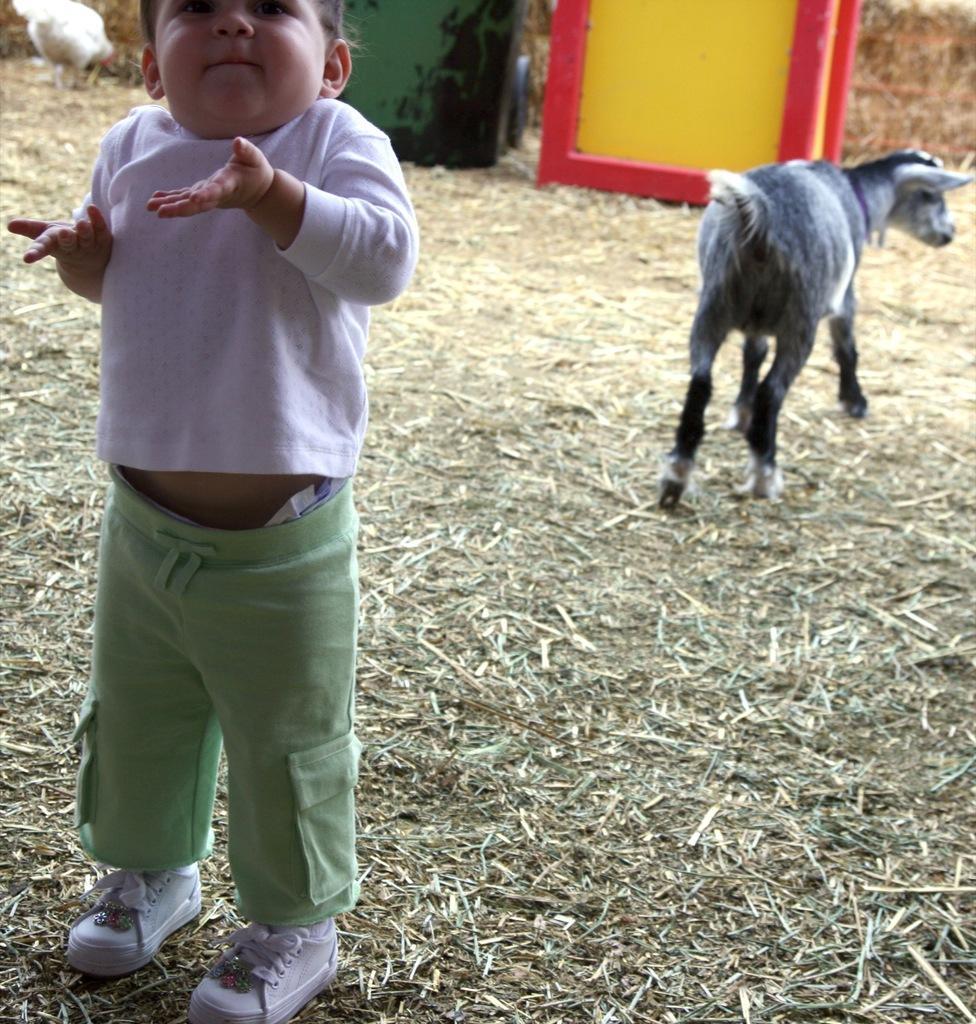Could you give a brief overview of what you see in this image? There is a goat in the image. There is a boy wearing white color shoes. At the bottom of the image there is grass. 